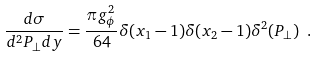Convert formula to latex. <formula><loc_0><loc_0><loc_500><loc_500>\frac { d \sigma } { d ^ { 2 } P _ { \perp } d y } = \frac { \pi g _ { \phi } ^ { 2 } } { 6 4 } \delta ( x _ { 1 } - 1 ) \delta ( x _ { 2 } - 1 ) \delta ^ { 2 } ( P _ { \perp } ) \ .</formula> 